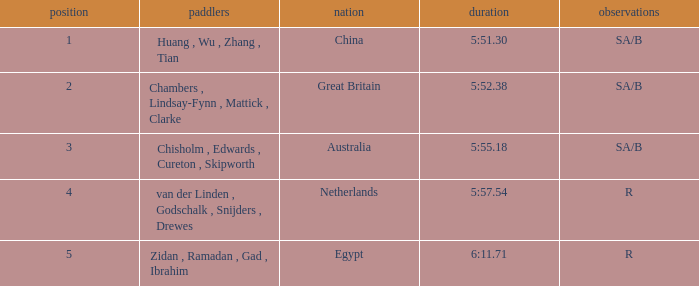Who were the rowers when notes were sa/b, with a time of 5:51.30? Huang , Wu , Zhang , Tian. 